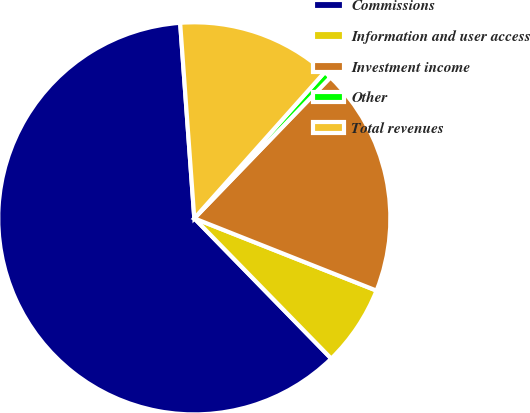<chart> <loc_0><loc_0><loc_500><loc_500><pie_chart><fcel>Commissions<fcel>Information and user access<fcel>Investment income<fcel>Other<fcel>Total revenues<nl><fcel>61.16%<fcel>6.68%<fcel>18.79%<fcel>0.63%<fcel>12.74%<nl></chart> 